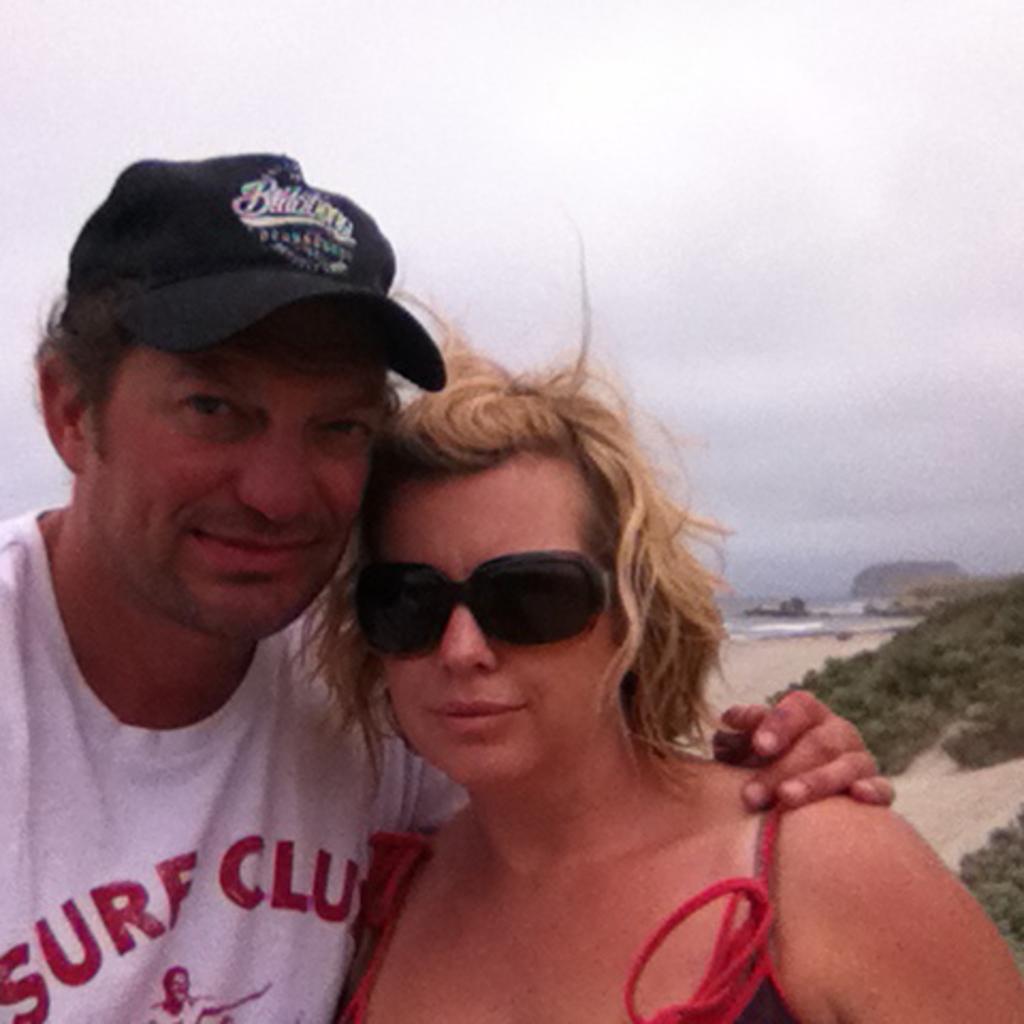How would you summarize this image in a sentence or two? In this image there is a couple standing, behind them there is a river, trees and the sky. 